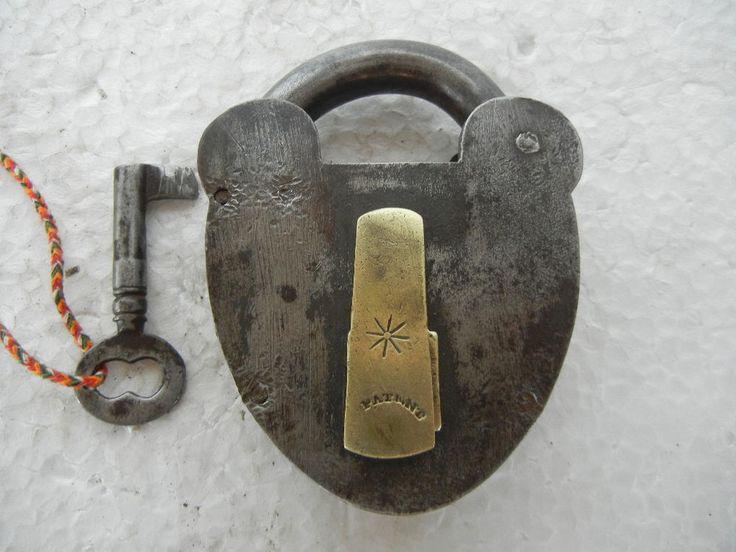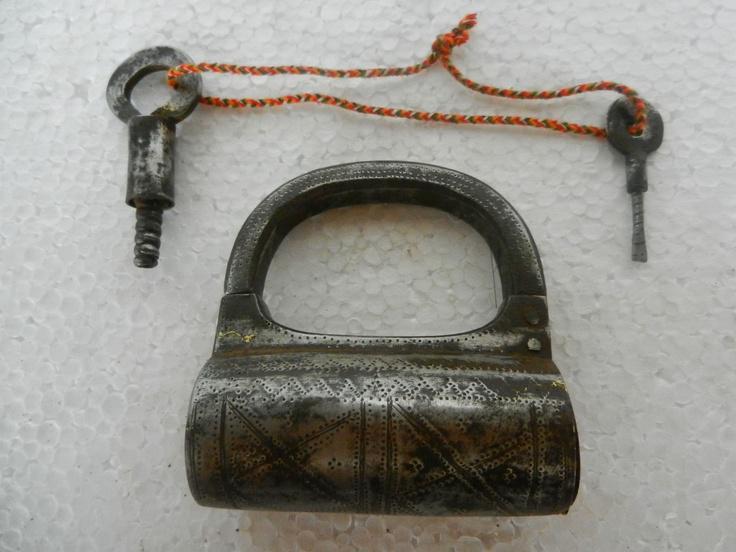The first image is the image on the left, the second image is the image on the right. For the images displayed, is the sentence "there are locks with the keys inserted in the bottom" factually correct? Answer yes or no. No. The first image is the image on the left, the second image is the image on the right. For the images shown, is this caption "There are no less than two keys inserted into padlocks" true? Answer yes or no. No. 